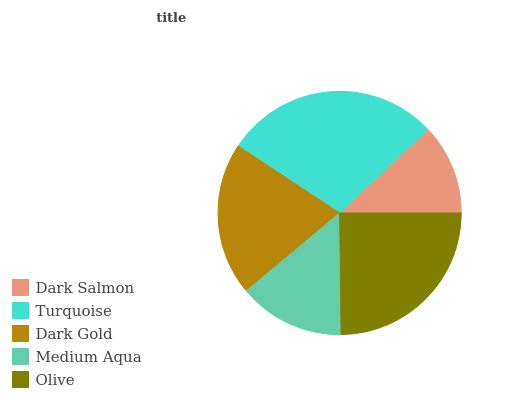Is Dark Salmon the minimum?
Answer yes or no. Yes. Is Turquoise the maximum?
Answer yes or no. Yes. Is Dark Gold the minimum?
Answer yes or no. No. Is Dark Gold the maximum?
Answer yes or no. No. Is Turquoise greater than Dark Gold?
Answer yes or no. Yes. Is Dark Gold less than Turquoise?
Answer yes or no. Yes. Is Dark Gold greater than Turquoise?
Answer yes or no. No. Is Turquoise less than Dark Gold?
Answer yes or no. No. Is Dark Gold the high median?
Answer yes or no. Yes. Is Dark Gold the low median?
Answer yes or no. Yes. Is Medium Aqua the high median?
Answer yes or no. No. Is Dark Salmon the low median?
Answer yes or no. No. 